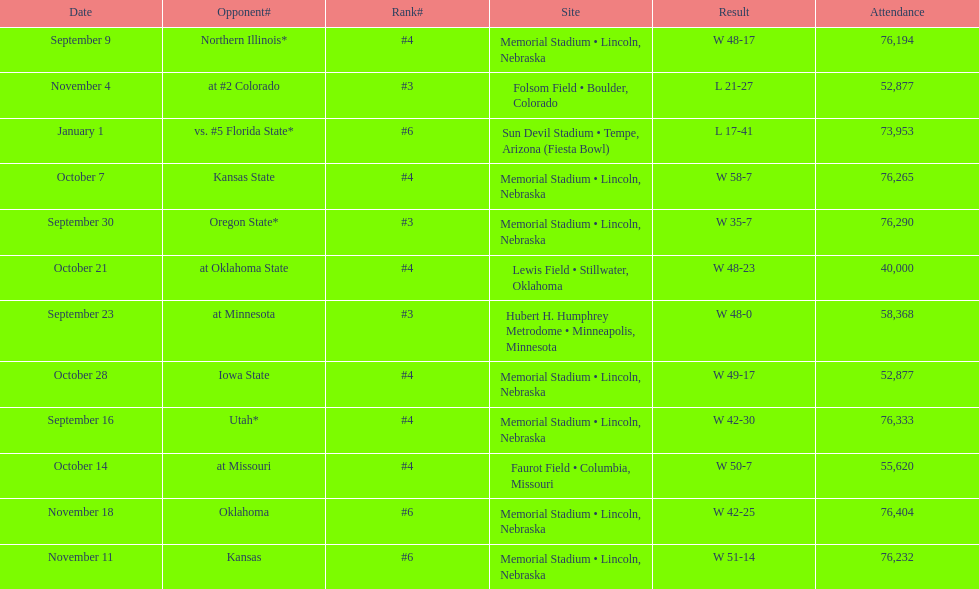On average how many times was w listed as the result? 10. 